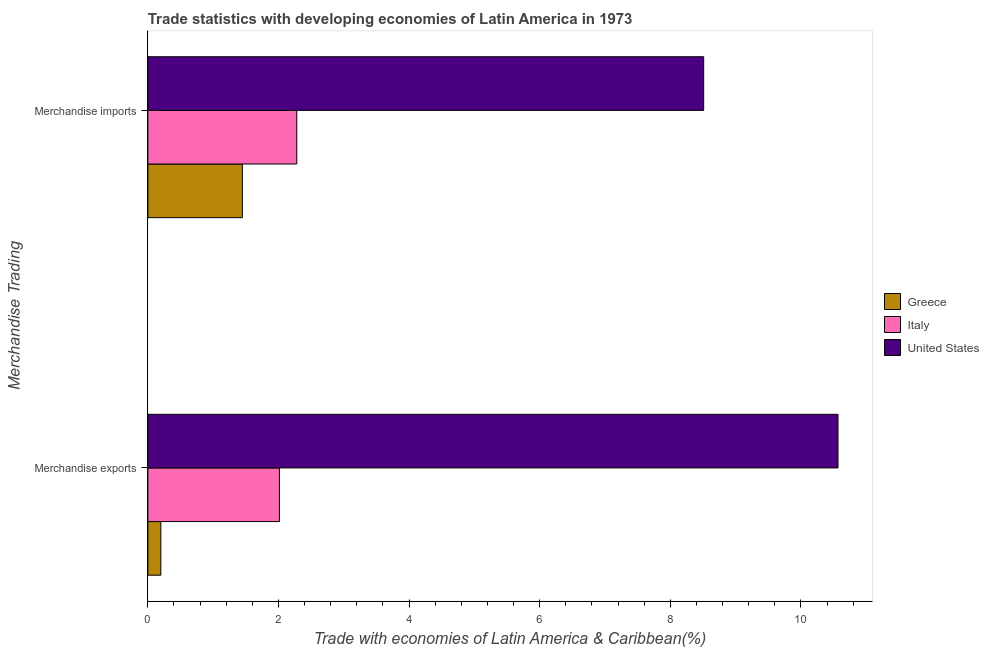Are the number of bars per tick equal to the number of legend labels?
Keep it short and to the point. Yes. Are the number of bars on each tick of the Y-axis equal?
Your response must be concise. Yes. How many bars are there on the 2nd tick from the bottom?
Ensure brevity in your answer.  3. What is the label of the 2nd group of bars from the top?
Keep it short and to the point. Merchandise exports. What is the merchandise exports in United States?
Your answer should be very brief. 10.57. Across all countries, what is the maximum merchandise exports?
Make the answer very short. 10.57. Across all countries, what is the minimum merchandise exports?
Your answer should be very brief. 0.2. In which country was the merchandise exports minimum?
Provide a short and direct response. Greece. What is the total merchandise exports in the graph?
Make the answer very short. 12.78. What is the difference between the merchandise exports in United States and that in Italy?
Your answer should be very brief. 8.55. What is the difference between the merchandise exports in Greece and the merchandise imports in Italy?
Offer a very short reply. -2.08. What is the average merchandise exports per country?
Make the answer very short. 4.26. What is the difference between the merchandise exports and merchandise imports in Italy?
Provide a succinct answer. -0.27. What is the ratio of the merchandise exports in Greece to that in Italy?
Give a very brief answer. 0.1. Where does the legend appear in the graph?
Your response must be concise. Center right. What is the title of the graph?
Make the answer very short. Trade statistics with developing economies of Latin America in 1973. Does "Korea (Republic)" appear as one of the legend labels in the graph?
Ensure brevity in your answer.  No. What is the label or title of the X-axis?
Make the answer very short. Trade with economies of Latin America & Caribbean(%). What is the label or title of the Y-axis?
Make the answer very short. Merchandise Trading. What is the Trade with economies of Latin America & Caribbean(%) in Greece in Merchandise exports?
Your answer should be very brief. 0.2. What is the Trade with economies of Latin America & Caribbean(%) in Italy in Merchandise exports?
Make the answer very short. 2.01. What is the Trade with economies of Latin America & Caribbean(%) in United States in Merchandise exports?
Make the answer very short. 10.57. What is the Trade with economies of Latin America & Caribbean(%) of Greece in Merchandise imports?
Keep it short and to the point. 1.45. What is the Trade with economies of Latin America & Caribbean(%) in Italy in Merchandise imports?
Ensure brevity in your answer.  2.28. What is the Trade with economies of Latin America & Caribbean(%) of United States in Merchandise imports?
Provide a short and direct response. 8.51. Across all Merchandise Trading, what is the maximum Trade with economies of Latin America & Caribbean(%) of Greece?
Provide a succinct answer. 1.45. Across all Merchandise Trading, what is the maximum Trade with economies of Latin America & Caribbean(%) of Italy?
Your response must be concise. 2.28. Across all Merchandise Trading, what is the maximum Trade with economies of Latin America & Caribbean(%) in United States?
Your answer should be very brief. 10.57. Across all Merchandise Trading, what is the minimum Trade with economies of Latin America & Caribbean(%) in Greece?
Your answer should be very brief. 0.2. Across all Merchandise Trading, what is the minimum Trade with economies of Latin America & Caribbean(%) of Italy?
Provide a short and direct response. 2.01. Across all Merchandise Trading, what is the minimum Trade with economies of Latin America & Caribbean(%) in United States?
Give a very brief answer. 8.51. What is the total Trade with economies of Latin America & Caribbean(%) in Greece in the graph?
Your answer should be compact. 1.65. What is the total Trade with economies of Latin America & Caribbean(%) in Italy in the graph?
Provide a succinct answer. 4.29. What is the total Trade with economies of Latin America & Caribbean(%) in United States in the graph?
Your answer should be very brief. 19.08. What is the difference between the Trade with economies of Latin America & Caribbean(%) of Greece in Merchandise exports and that in Merchandise imports?
Your answer should be very brief. -1.25. What is the difference between the Trade with economies of Latin America & Caribbean(%) in Italy in Merchandise exports and that in Merchandise imports?
Make the answer very short. -0.27. What is the difference between the Trade with economies of Latin America & Caribbean(%) of United States in Merchandise exports and that in Merchandise imports?
Give a very brief answer. 2.06. What is the difference between the Trade with economies of Latin America & Caribbean(%) of Greece in Merchandise exports and the Trade with economies of Latin America & Caribbean(%) of Italy in Merchandise imports?
Keep it short and to the point. -2.08. What is the difference between the Trade with economies of Latin America & Caribbean(%) in Greece in Merchandise exports and the Trade with economies of Latin America & Caribbean(%) in United States in Merchandise imports?
Provide a short and direct response. -8.31. What is the difference between the Trade with economies of Latin America & Caribbean(%) in Italy in Merchandise exports and the Trade with economies of Latin America & Caribbean(%) in United States in Merchandise imports?
Offer a very short reply. -6.5. What is the average Trade with economies of Latin America & Caribbean(%) of Greece per Merchandise Trading?
Give a very brief answer. 0.82. What is the average Trade with economies of Latin America & Caribbean(%) in Italy per Merchandise Trading?
Keep it short and to the point. 2.15. What is the average Trade with economies of Latin America & Caribbean(%) in United States per Merchandise Trading?
Your response must be concise. 9.54. What is the difference between the Trade with economies of Latin America & Caribbean(%) of Greece and Trade with economies of Latin America & Caribbean(%) of Italy in Merchandise exports?
Ensure brevity in your answer.  -1.82. What is the difference between the Trade with economies of Latin America & Caribbean(%) in Greece and Trade with economies of Latin America & Caribbean(%) in United States in Merchandise exports?
Your answer should be very brief. -10.37. What is the difference between the Trade with economies of Latin America & Caribbean(%) of Italy and Trade with economies of Latin America & Caribbean(%) of United States in Merchandise exports?
Provide a short and direct response. -8.55. What is the difference between the Trade with economies of Latin America & Caribbean(%) in Greece and Trade with economies of Latin America & Caribbean(%) in Italy in Merchandise imports?
Make the answer very short. -0.83. What is the difference between the Trade with economies of Latin America & Caribbean(%) in Greece and Trade with economies of Latin America & Caribbean(%) in United States in Merchandise imports?
Make the answer very short. -7.06. What is the difference between the Trade with economies of Latin America & Caribbean(%) of Italy and Trade with economies of Latin America & Caribbean(%) of United States in Merchandise imports?
Keep it short and to the point. -6.23. What is the ratio of the Trade with economies of Latin America & Caribbean(%) in Greece in Merchandise exports to that in Merchandise imports?
Ensure brevity in your answer.  0.14. What is the ratio of the Trade with economies of Latin America & Caribbean(%) of Italy in Merchandise exports to that in Merchandise imports?
Offer a very short reply. 0.88. What is the ratio of the Trade with economies of Latin America & Caribbean(%) in United States in Merchandise exports to that in Merchandise imports?
Provide a succinct answer. 1.24. What is the difference between the highest and the second highest Trade with economies of Latin America & Caribbean(%) in Greece?
Provide a succinct answer. 1.25. What is the difference between the highest and the second highest Trade with economies of Latin America & Caribbean(%) in Italy?
Your answer should be compact. 0.27. What is the difference between the highest and the second highest Trade with economies of Latin America & Caribbean(%) in United States?
Offer a terse response. 2.06. What is the difference between the highest and the lowest Trade with economies of Latin America & Caribbean(%) in Greece?
Make the answer very short. 1.25. What is the difference between the highest and the lowest Trade with economies of Latin America & Caribbean(%) of Italy?
Your response must be concise. 0.27. What is the difference between the highest and the lowest Trade with economies of Latin America & Caribbean(%) in United States?
Keep it short and to the point. 2.06. 